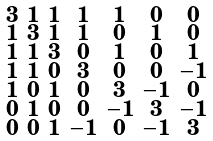<formula> <loc_0><loc_0><loc_500><loc_500>\begin{smallmatrix} 3 & 1 & 1 & 1 & 1 & 0 & 0 \\ 1 & 3 & 1 & 1 & 0 & 1 & 0 \\ 1 & 1 & 3 & 0 & 1 & 0 & 1 \\ 1 & 1 & 0 & 3 & 0 & 0 & - 1 \\ 1 & 0 & 1 & 0 & 3 & - 1 & 0 \\ 0 & 1 & 0 & 0 & - 1 & 3 & - 1 \\ 0 & 0 & 1 & - 1 & 0 & - 1 & 3 \end{smallmatrix}</formula> 